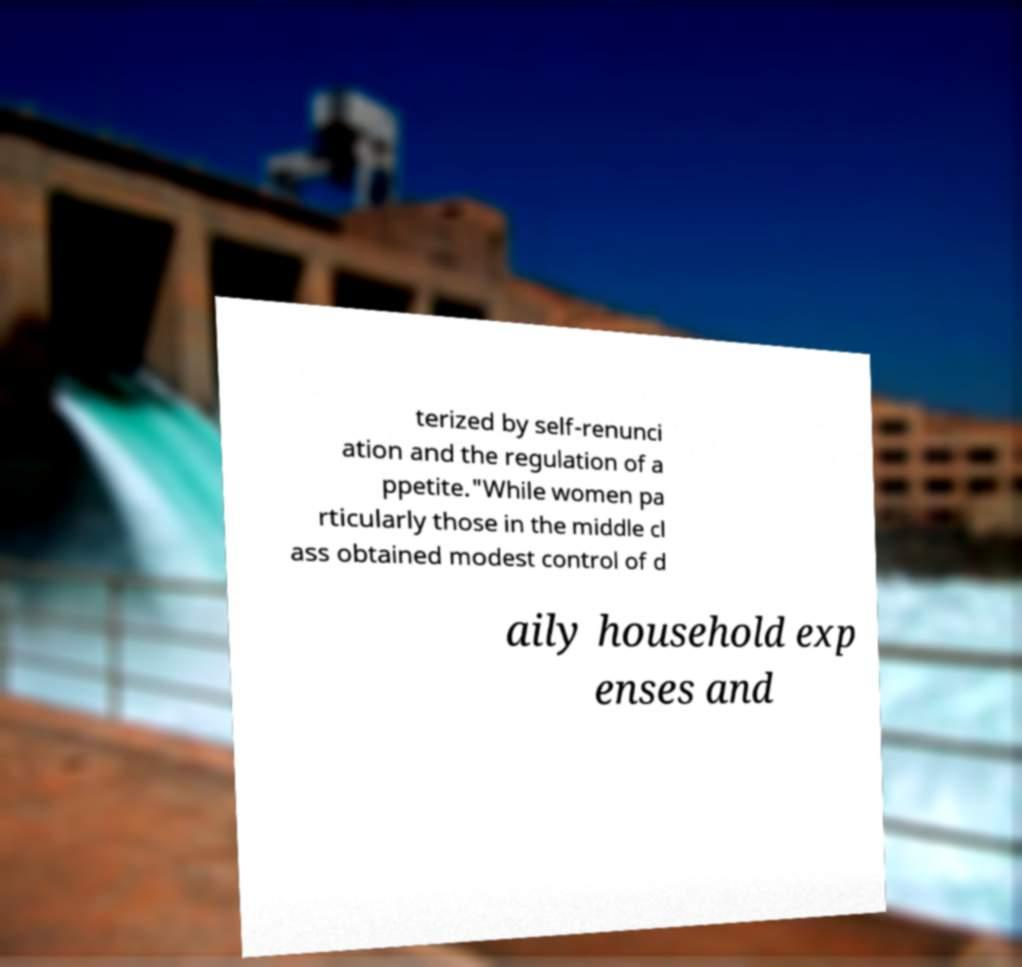Please read and relay the text visible in this image. What does it say? terized by self-renunci ation and the regulation of a ppetite."While women pa rticularly those in the middle cl ass obtained modest control of d aily household exp enses and 